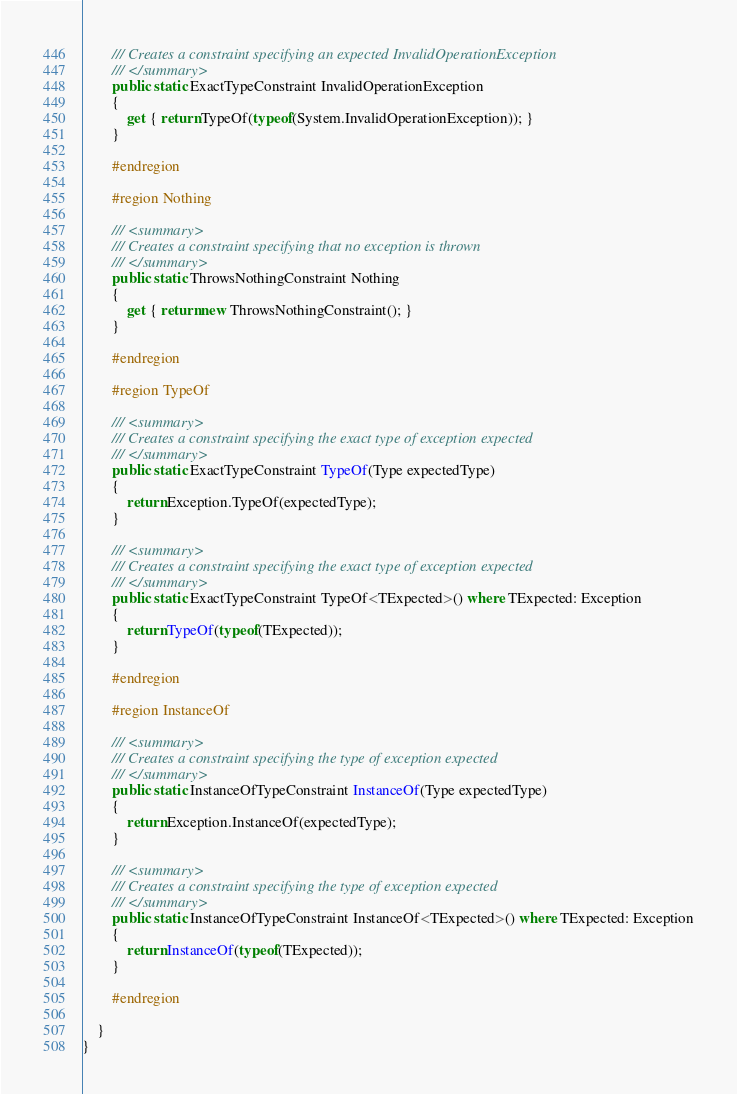Convert code to text. <code><loc_0><loc_0><loc_500><loc_500><_C#_>        /// Creates a constraint specifying an expected InvalidOperationException
        /// </summary>
        public static ExactTypeConstraint InvalidOperationException
        {
            get { return TypeOf(typeof(System.InvalidOperationException)); }
        }

        #endregion

        #region Nothing

        /// <summary>
        /// Creates a constraint specifying that no exception is thrown
        /// </summary>
        public static ThrowsNothingConstraint Nothing
        {
            get { return new ThrowsNothingConstraint(); }
        }

        #endregion

        #region TypeOf

        /// <summary>
        /// Creates a constraint specifying the exact type of exception expected
        /// </summary>
        public static ExactTypeConstraint TypeOf(Type expectedType)
        {
            return Exception.TypeOf(expectedType);
        }

        /// <summary>
        /// Creates a constraint specifying the exact type of exception expected
        /// </summary>
        public static ExactTypeConstraint TypeOf<TExpected>() where TExpected: Exception
        {
            return TypeOf(typeof(TExpected));
        }

        #endregion

        #region InstanceOf

        /// <summary>
        /// Creates a constraint specifying the type of exception expected
        /// </summary>
        public static InstanceOfTypeConstraint InstanceOf(Type expectedType)
        {
            return Exception.InstanceOf(expectedType);
        }

        /// <summary>
        /// Creates a constraint specifying the type of exception expected
        /// </summary>
        public static InstanceOfTypeConstraint InstanceOf<TExpected>() where TExpected: Exception
        {
            return InstanceOf(typeof(TExpected));
        }

        #endregion

    }
}
</code> 